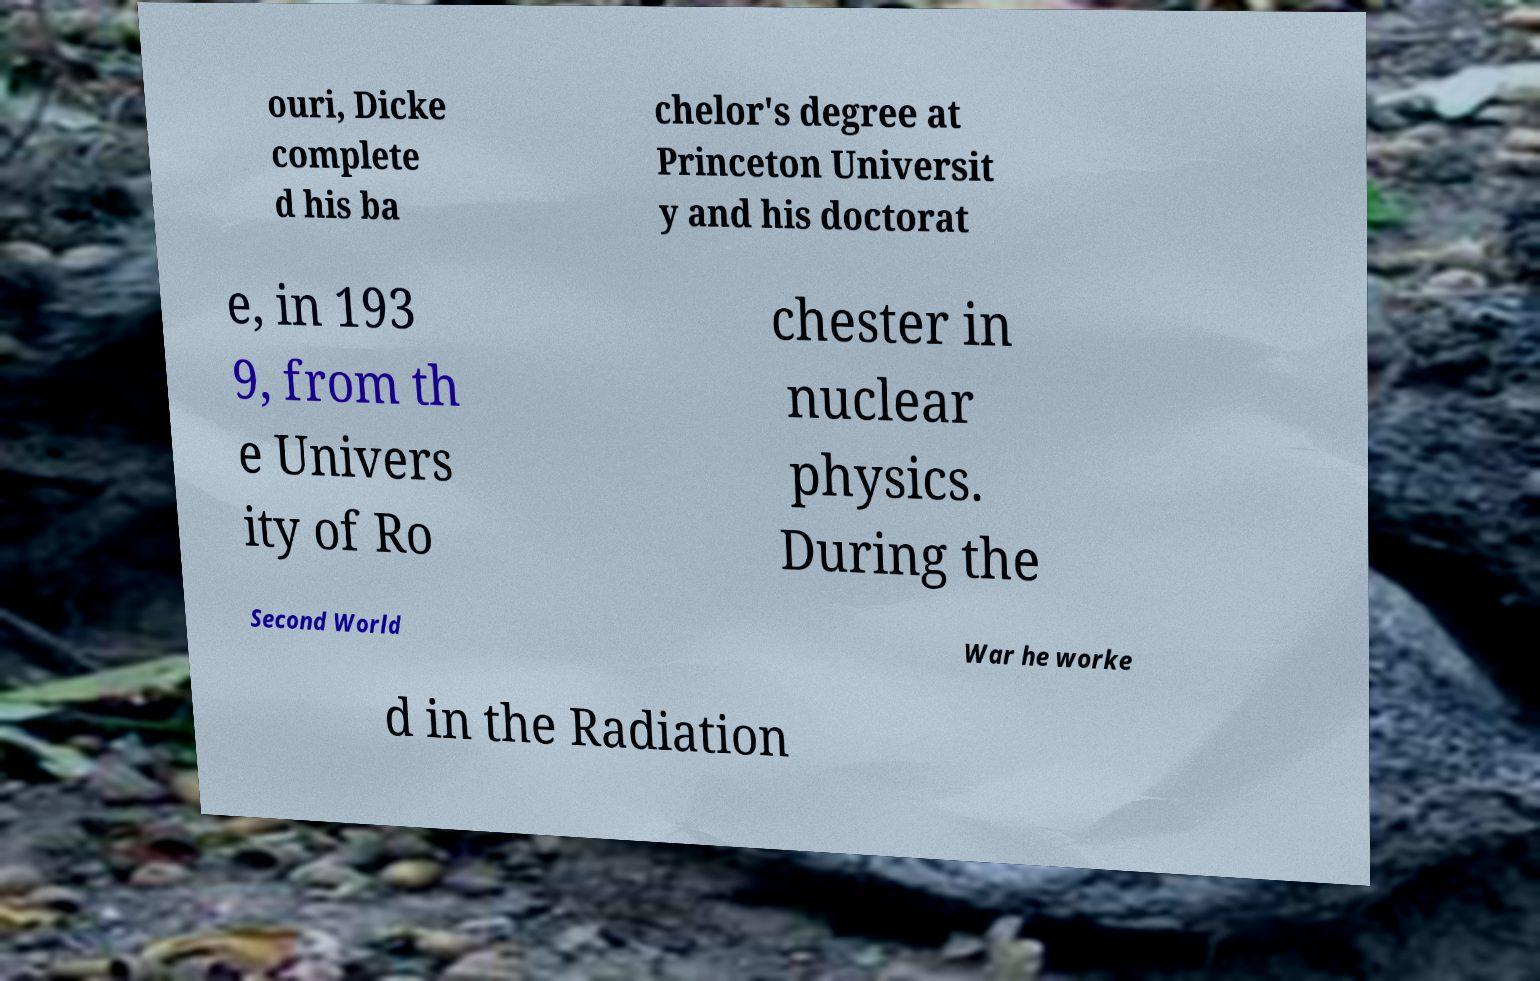Can you read and provide the text displayed in the image?This photo seems to have some interesting text. Can you extract and type it out for me? ouri, Dicke complete d his ba chelor's degree at Princeton Universit y and his doctorat e, in 193 9, from th e Univers ity of Ro chester in nuclear physics. During the Second World War he worke d in the Radiation 